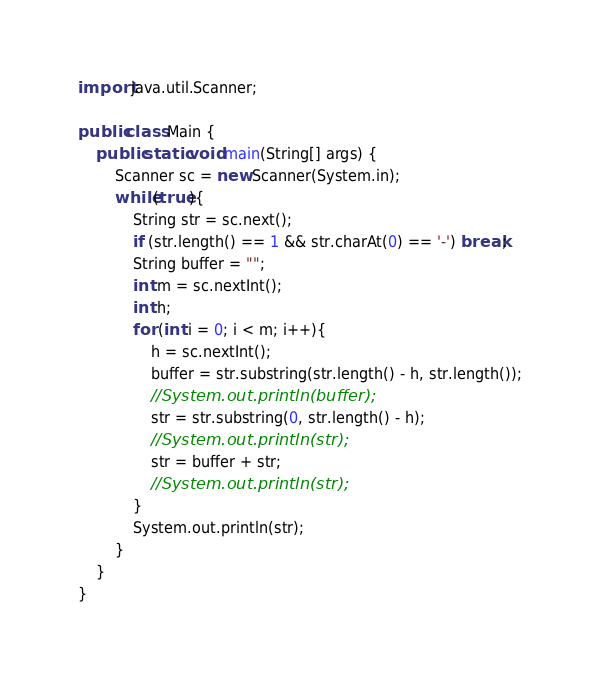<code> <loc_0><loc_0><loc_500><loc_500><_Java_>import java.util.Scanner;

public class Main {	
	public static void main(String[] args) {
		Scanner sc = new Scanner(System.in);
		while(true){
			String str = sc.next();
			if (str.length() == 1 && str.charAt(0) == '-') break;
			String buffer = "";
			int m = sc.nextInt();
			int h;
			for (int i = 0; i < m; i++){
				h = sc.nextInt();
				buffer = str.substring(str.length() - h, str.length());
				//System.out.println(buffer);
				str = str.substring(0, str.length() - h);
				//System.out.println(str);
				str = buffer + str;
				//System.out.println(str);
			}
			System.out.println(str);
		}
	}
}</code> 